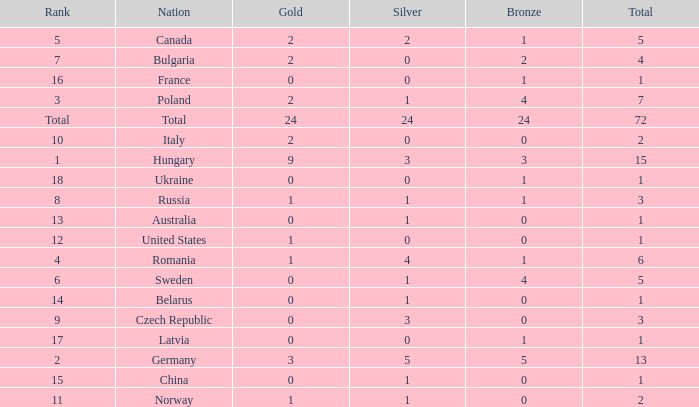Would you be able to parse every entry in this table? {'header': ['Rank', 'Nation', 'Gold', 'Silver', 'Bronze', 'Total'], 'rows': [['5', 'Canada', '2', '2', '1', '5'], ['7', 'Bulgaria', '2', '0', '2', '4'], ['16', 'France', '0', '0', '1', '1'], ['3', 'Poland', '2', '1', '4', '7'], ['Total', 'Total', '24', '24', '24', '72'], ['10', 'Italy', '2', '0', '0', '2'], ['1', 'Hungary', '9', '3', '3', '15'], ['18', 'Ukraine', '0', '0', '1', '1'], ['8', 'Russia', '1', '1', '1', '3'], ['13', 'Australia', '0', '1', '0', '1'], ['12', 'United States', '1', '0', '0', '1'], ['4', 'Romania', '1', '4', '1', '6'], ['6', 'Sweden', '0', '1', '4', '5'], ['14', 'Belarus', '0', '1', '0', '1'], ['9', 'Czech Republic', '0', '3', '0', '3'], ['17', 'Latvia', '0', '0', '1', '1'], ['2', 'Germany', '3', '5', '5', '13'], ['15', 'China', '0', '1', '0', '1'], ['11', 'Norway', '1', '1', '0', '2']]} How many golds have 3 as the rank, with a total greater than 7? 0.0. 